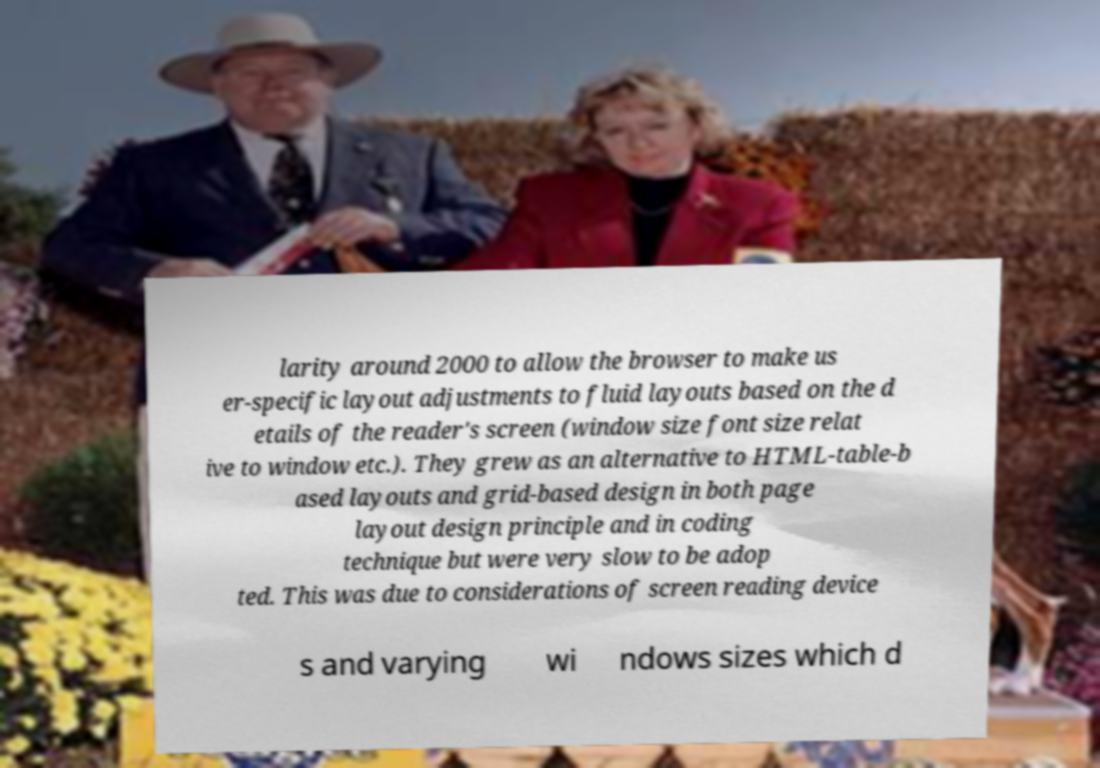There's text embedded in this image that I need extracted. Can you transcribe it verbatim? larity around 2000 to allow the browser to make us er-specific layout adjustments to fluid layouts based on the d etails of the reader's screen (window size font size relat ive to window etc.). They grew as an alternative to HTML-table-b ased layouts and grid-based design in both page layout design principle and in coding technique but were very slow to be adop ted. This was due to considerations of screen reading device s and varying wi ndows sizes which d 